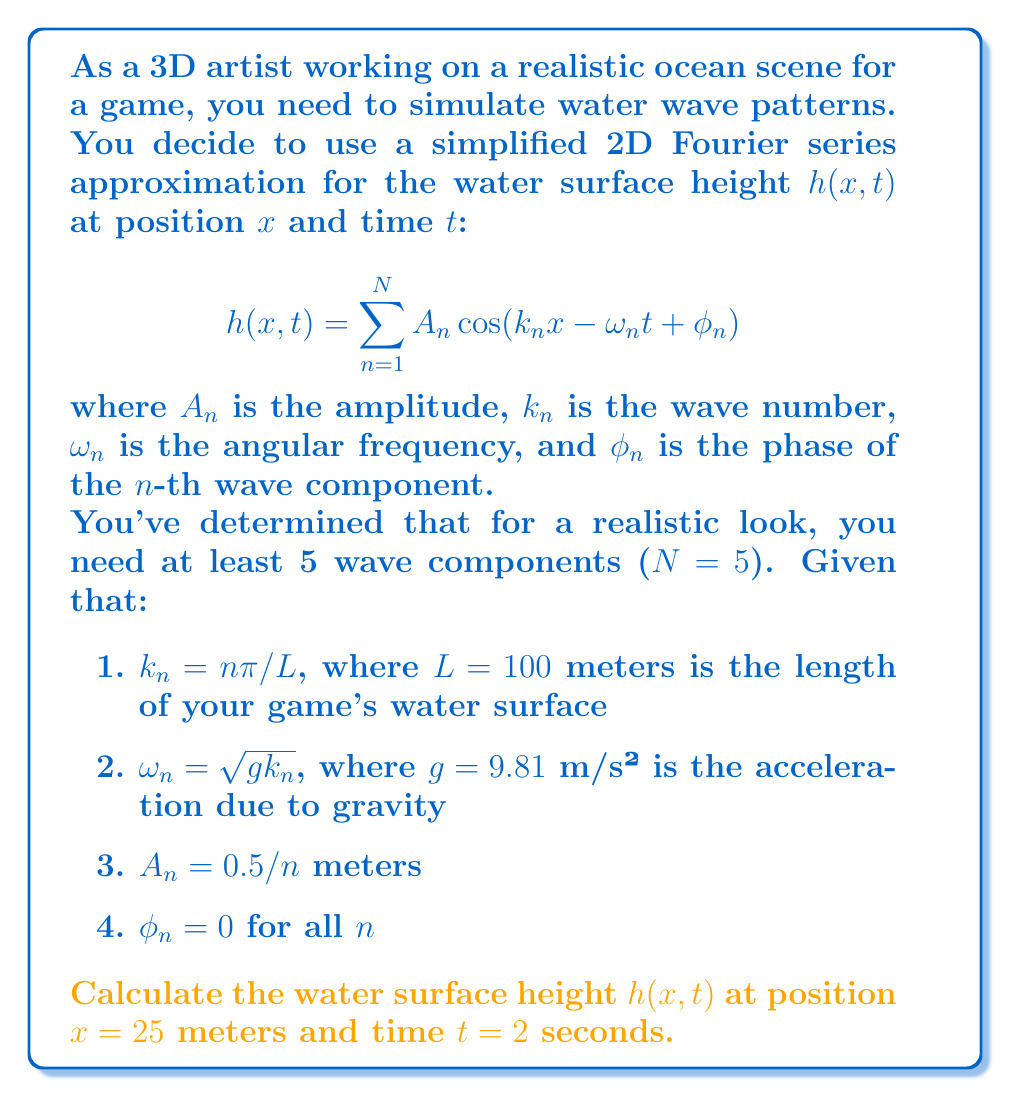Teach me how to tackle this problem. Let's approach this step-by-step:

1) First, we need to calculate $k_n$ and $\omega_n$ for each of the 5 components:

   For $n=1$ to $5$:
   $k_n = n\pi/L = n\pi/100$
   $\omega_n = \sqrt{gk_n} = \sqrt{9.81 \cdot n\pi/100}$

2) Now, let's calculate each term in the sum:

   For $n=1$:
   $A_1 = 0.5/1 = 0.5$
   $k_1x - \omega_1t = \pi/4 - \sqrt{0.3084\pi} \cdot 2$
   $h_1 = 0.5 \cos(\pi/4 - \sqrt{0.3084\pi} \cdot 2)$

   For $n=2$:
   $A_2 = 0.5/2 = 0.25$
   $k_2x - \omega_2t = \pi/2 - \sqrt{0.6168\pi} \cdot 2$
   $h_2 = 0.25 \cos(\pi/2 - \sqrt{0.6168\pi} \cdot 2)$

   For $n=3$:
   $A_3 = 0.5/3 \approx 0.1667$
   $k_3x - \omega_3t = 3\pi/4 - \sqrt{0.9252\pi} \cdot 2$
   $h_3 = 0.1667 \cos(3\pi/4 - \sqrt{0.9252\pi} \cdot 2)$

   For $n=4$:
   $A_4 = 0.5/4 = 0.125$
   $k_4x - \omega_4t = \pi - \sqrt{1.2336\pi} \cdot 2$
   $h_4 = 0.125 \cos(\pi - \sqrt{1.2336\pi} \cdot 2)$

   For $n=5$:
   $A_5 = 0.5/5 = 0.1$
   $k_5x - \omega_5t = 5\pi/4 - \sqrt{1.542\pi} \cdot 2$
   $h_5 = 0.1 \cos(5\pi/4 - \sqrt{1.542\pi} \cdot 2)$

3) The final height is the sum of these components:

   $h(25,2) = h_1 + h_2 + h_3 + h_4 + h_5$

4) Calculating this sum (which involves irrational numbers) gives us approximately 0.2134 meters.
Answer: $h(25,2) \approx 0.2134$ meters 